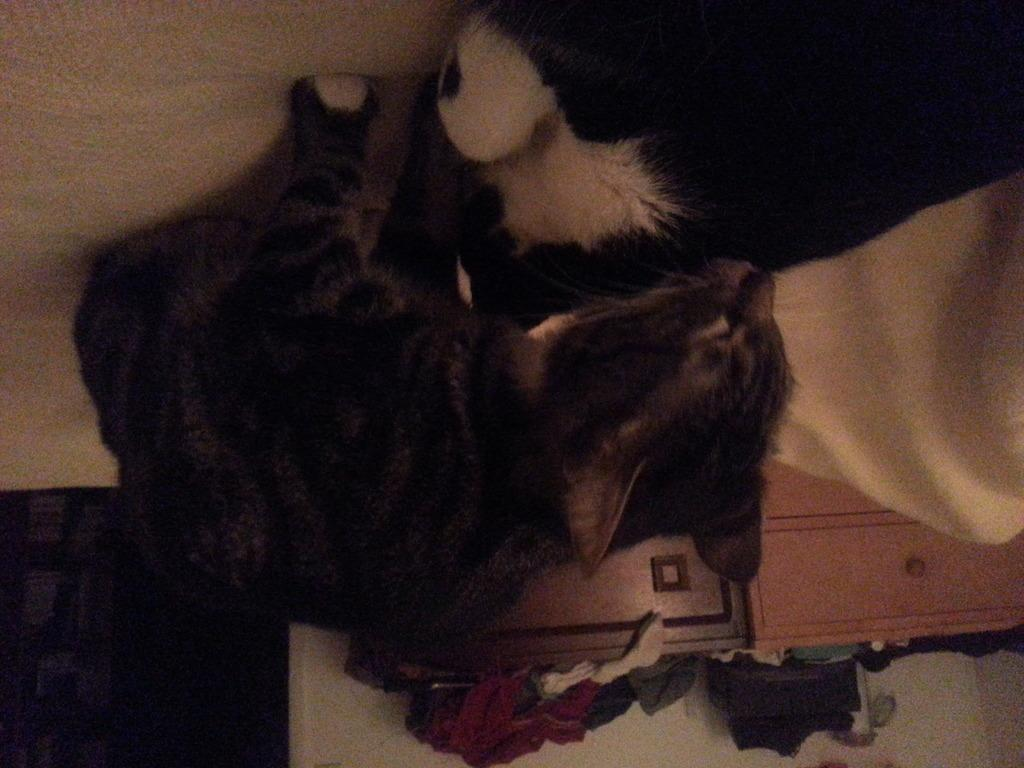What type of animals are in the image? There are cats in the image. What object can be seen in the image besides the cats? There is a cloth in the image. What can be seen in the background of the image? There are stands and a wall in the background of the image. Where is the crib located in the image? There is no crib present in the image. 